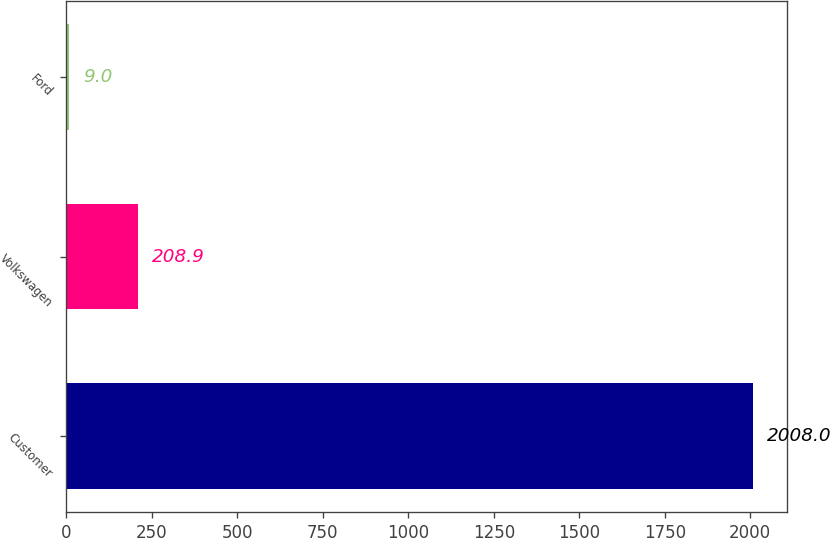Convert chart to OTSL. <chart><loc_0><loc_0><loc_500><loc_500><bar_chart><fcel>Customer<fcel>Volkswagen<fcel>Ford<nl><fcel>2008<fcel>208.9<fcel>9<nl></chart> 